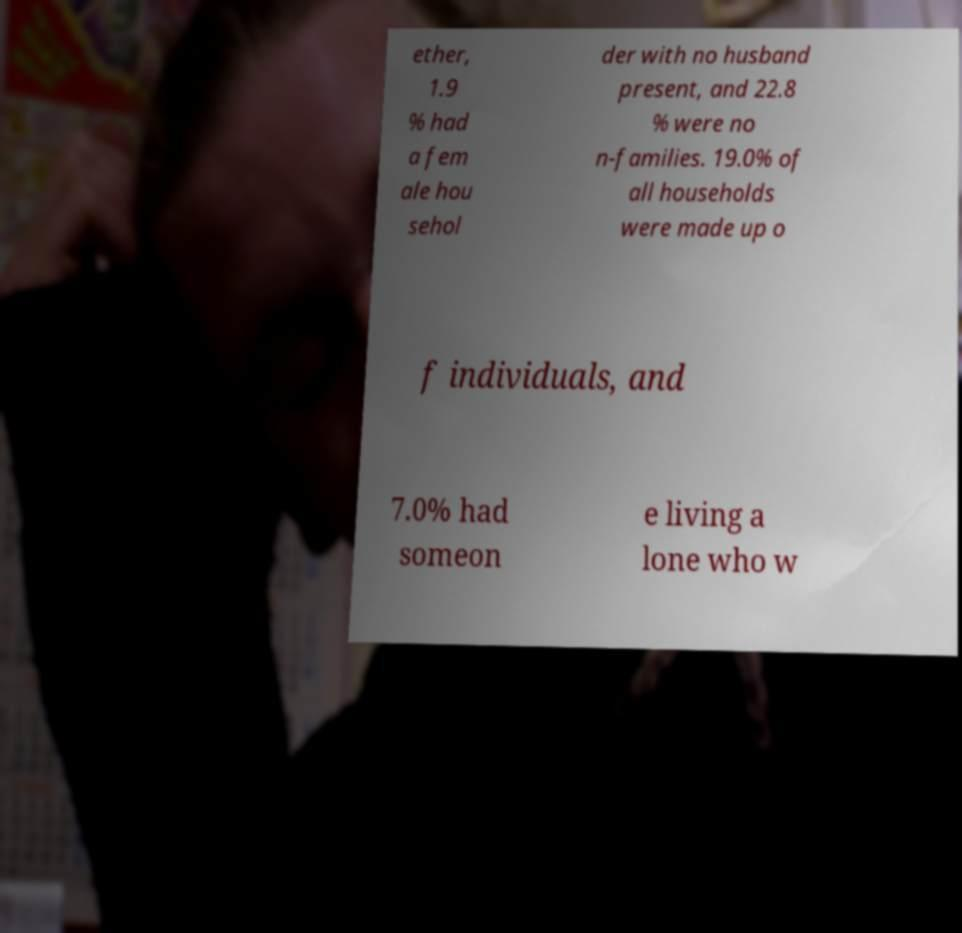Can you accurately transcribe the text from the provided image for me? ether, 1.9 % had a fem ale hou sehol der with no husband present, and 22.8 % were no n-families. 19.0% of all households were made up o f individuals, and 7.0% had someon e living a lone who w 